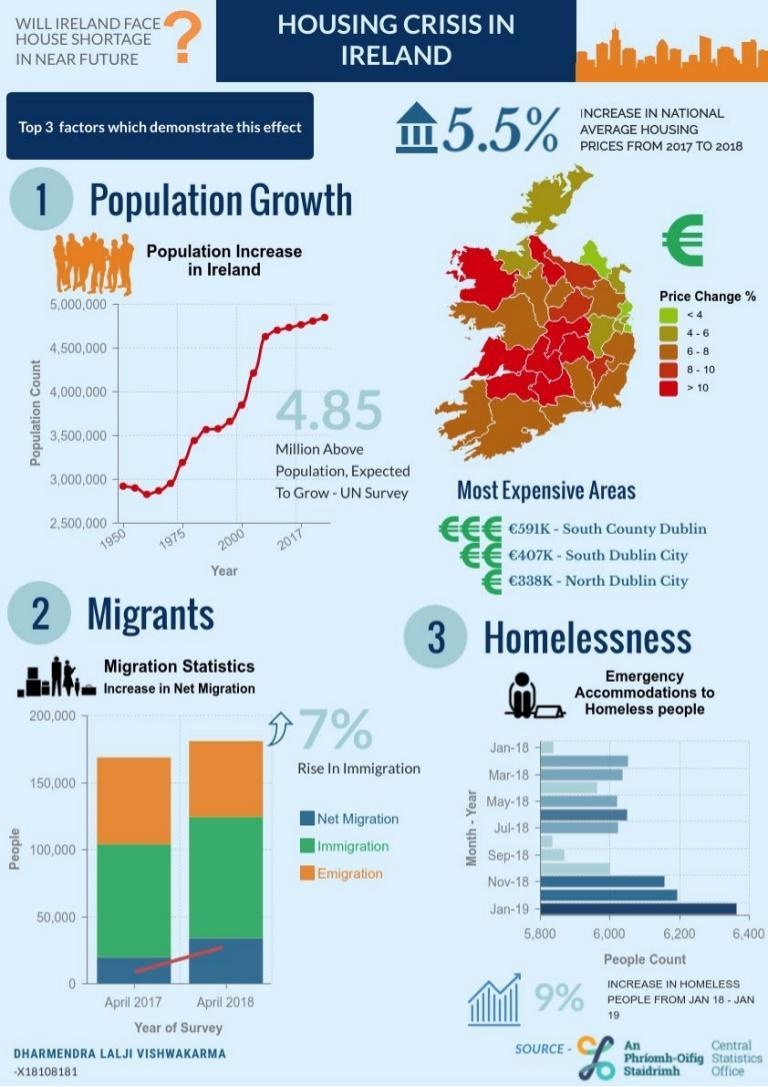Which factors affect Ireland's housing shortage problem?
Answer the question with a short phrase. Population Growth, Migrants, Homelessness 